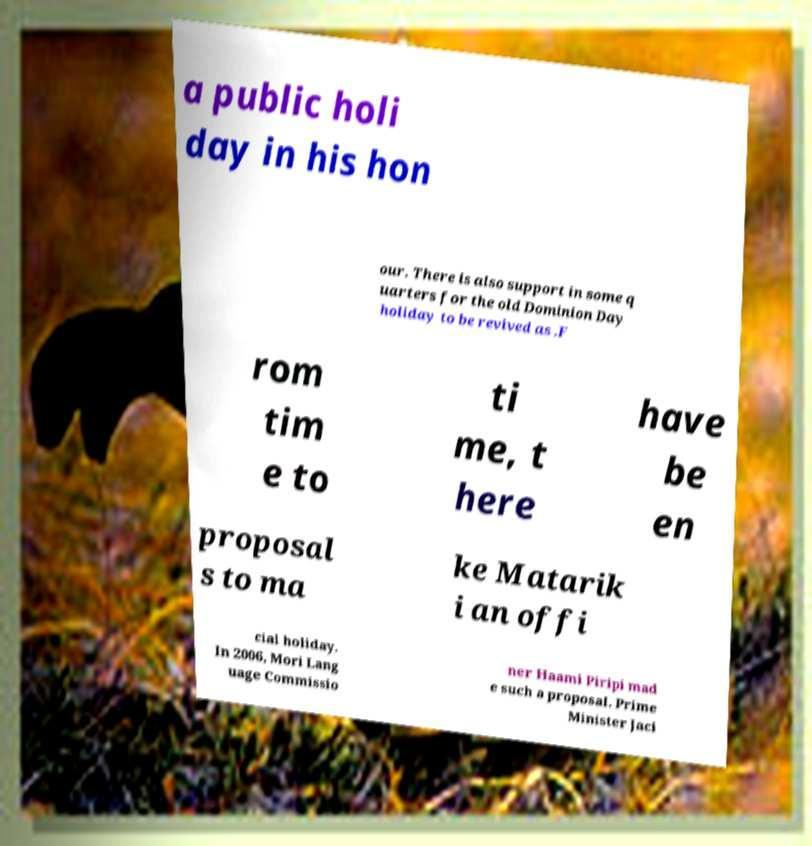For documentation purposes, I need the text within this image transcribed. Could you provide that? a public holi day in his hon our. There is also support in some q uarters for the old Dominion Day holiday to be revived as .F rom tim e to ti me, t here have be en proposal s to ma ke Matarik i an offi cial holiday. In 2006, Mori Lang uage Commissio ner Haami Piripi mad e such a proposal. Prime Minister Jaci 